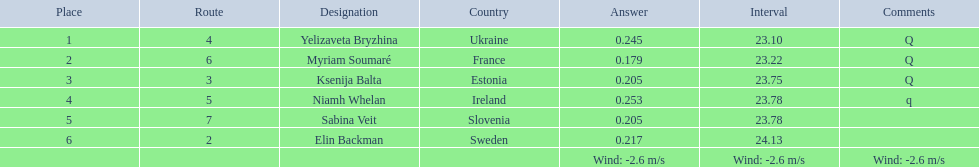What are all the names? Yelizaveta Bryzhina, Myriam Soumaré, Ksenija Balta, Niamh Whelan, Sabina Veit, Elin Backman. What were their finishing times? 23.10, 23.22, 23.75, 23.78, 23.78, 24.13. And which time was reached by ellen backman? 24.13. 